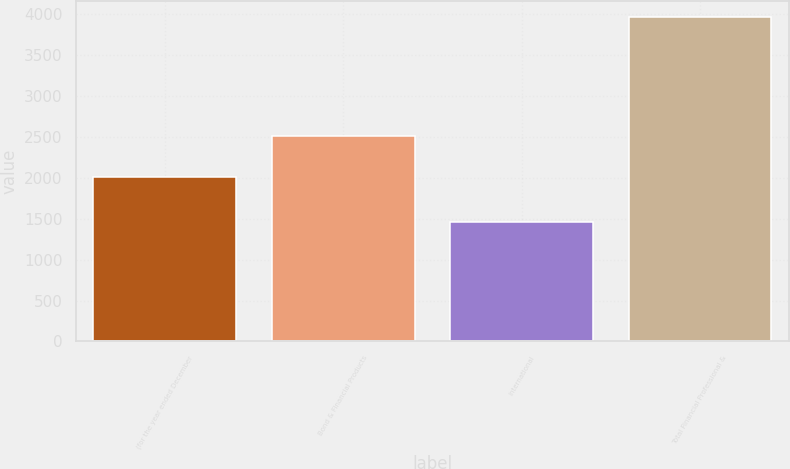<chart> <loc_0><loc_0><loc_500><loc_500><bar_chart><fcel>(for the year ended December<fcel>Bond & Financial Products<fcel>International<fcel>Total Financial Professional &<nl><fcel>2008<fcel>2507<fcel>1459<fcel>3966<nl></chart> 